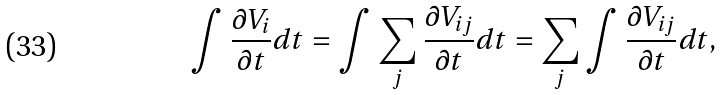Convert formula to latex. <formula><loc_0><loc_0><loc_500><loc_500>\int \frac { \partial V _ { i } } { \partial t } d t = \int \sum _ { j } \frac { \partial V _ { i j } } { \partial t } d t = \sum _ { j } \int \frac { \partial V _ { i j } } { \partial t } d t ,</formula> 